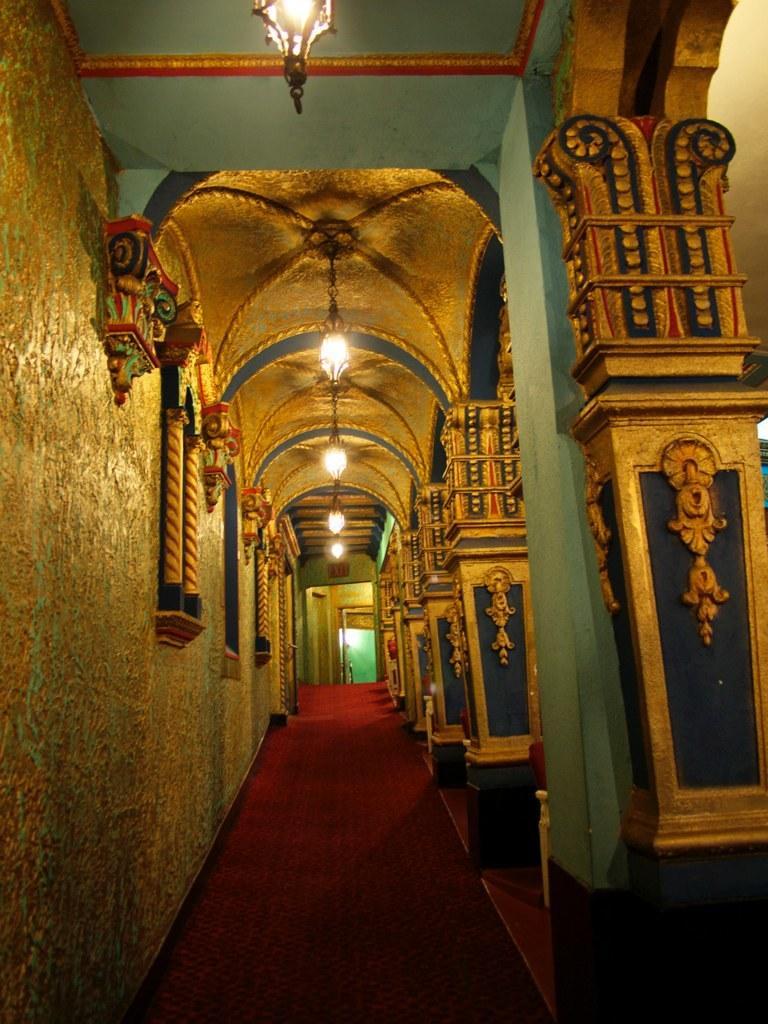How would you summarize this image in a sentence or two? In this image I can see few lights, background I can see few pillars and the wall in blue, yellow and red color, a red color carpet. Background I can see a green color door. 